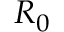Convert formula to latex. <formula><loc_0><loc_0><loc_500><loc_500>R _ { 0 }</formula> 